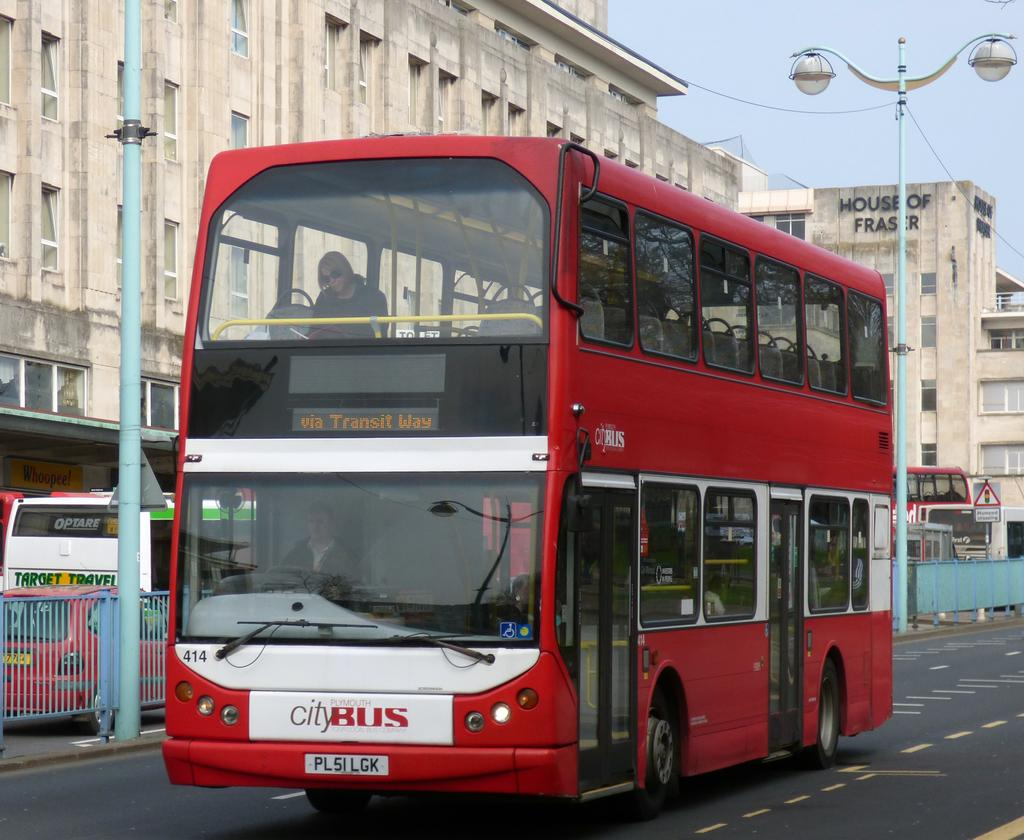Provide a one-sentence caption for the provided image. Red and white double decker bus that reads "via Transit Way". 